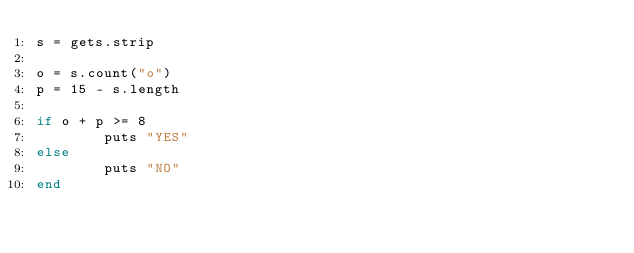<code> <loc_0><loc_0><loc_500><loc_500><_Ruby_>s = gets.strip

o = s.count("o")
p = 15 - s.length

if o + p >= 8
        puts "YES"
else
        puts "NO"
end</code> 